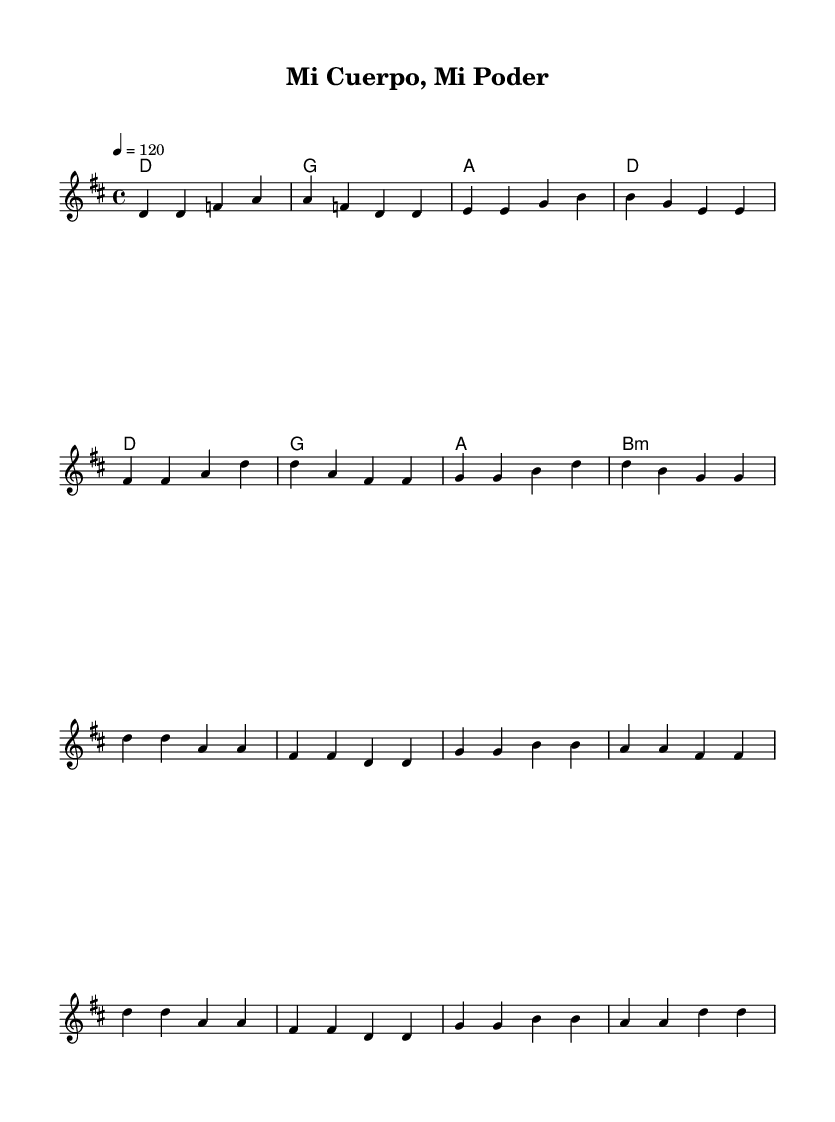What is the key signature of this music? The key signature at the beginning of the sheet music indicates that there are two sharps, which corresponds to D major.
Answer: D major What is the time signature of this piece? The time signature shown in the sheet music is 4/4, meaning there are four beats in each measure.
Answer: 4/4 What is the tempo marking for this piece? The tempo marking states "4 = 120," which indicates that the quarter note should be played at a speed of 120 beats per minute.
Answer: 120 How many measures are in the chorus section? The chorus section consists of four measures based on the notation in the score.
Answer: Four What are the first two chords played in the verse? The harmony line shows that the first two chords in the verse are D major and G major.
Answer: D, G Which chord comes before the B minor chord in the chorus? A major chord immediately precedes the B minor chord in the chorus based on the harmony notations.
Answer: A What is the mood implied by the song title and melody? The upbeat melody combined with the title "Mi Cuerpo, Mi Poder" suggests themes of self-empowerment and positivity.
Answer: Empowerment 